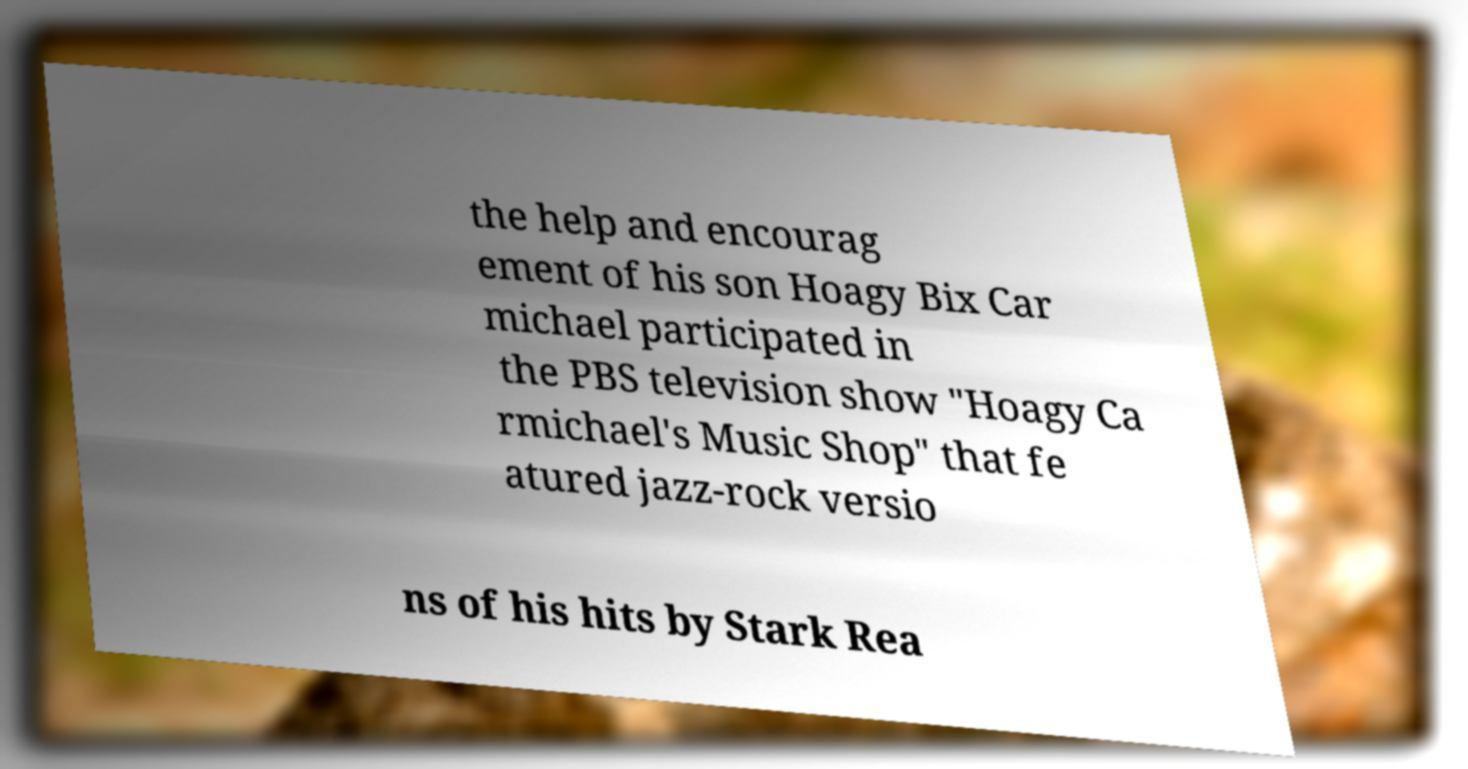Please read and relay the text visible in this image. What does it say? the help and encourag ement of his son Hoagy Bix Car michael participated in the PBS television show "Hoagy Ca rmichael's Music Shop" that fe atured jazz-rock versio ns of his hits by Stark Rea 